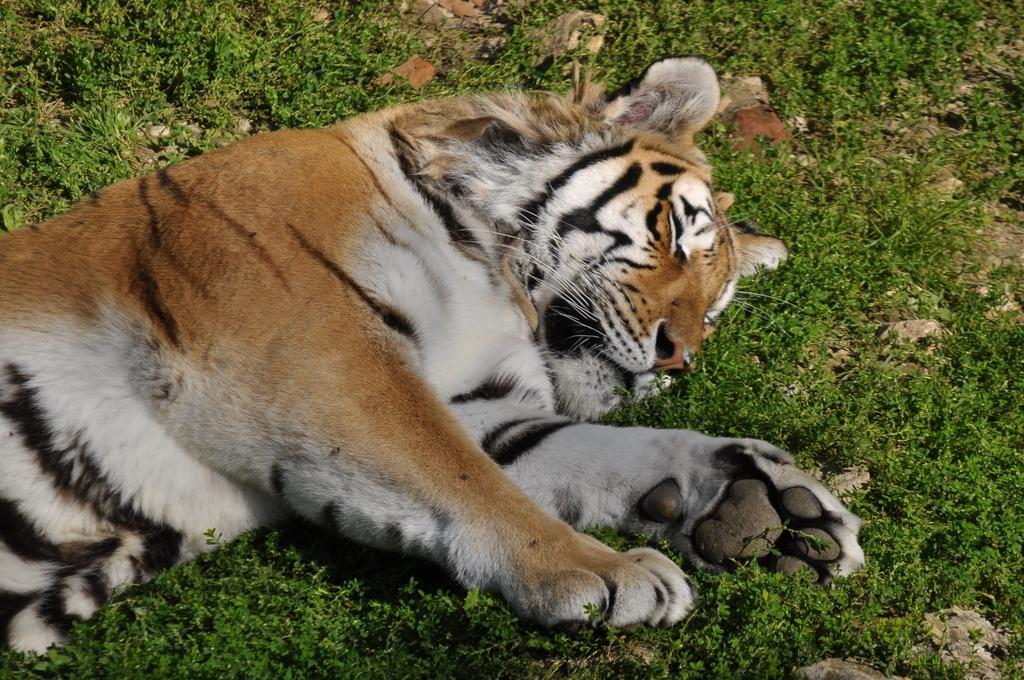What type of terrain is depicted in the image? The image shows stones and grass on the ground. What animal can be seen lying on the ground in the image? There is a tiger lying on the ground in the image. What type of light source is illuminating the tiger in the image? There is no specific light source mentioned or depicted in the image, so it cannot be determined. 